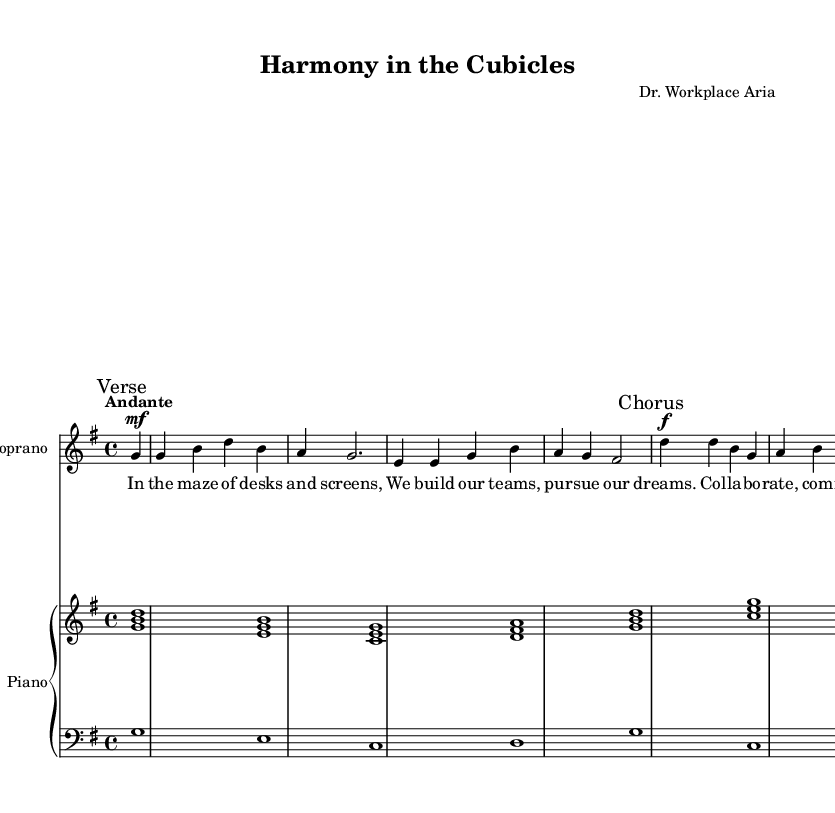What is the key signature of this music? The key signature is indicated at the beginning of the musical staff in the global variable. The presence of one sharp indicates it's in G major.
Answer: G major What is the time signature of this music? The time signature is shown in the global variable at the start of the score. It is noted as 4/4.
Answer: 4/4 What is the tempo marking of this music? The tempo marking is indicated in the global variable right above the vocal and instrumental parts. It states "Andante".
Answer: Andante How many measures are in the verse section? By counting the measures of the verse section provided in the soprano part below the verse mark, we find there are four measures.
Answer: Four How does the melody of the chorus compare to the verse? The chorus has a higher melodic range and dynamic, which can be inferred from the soprano part, identified by louder dynamics and a different pattern of notes compared to the verse section.
Answer: Higher melodic range What is the main theme of the lyrics? The lyrics focus on collaboration and teamwork, as evidenced by lines such as "We build our teams, pursue our dreams" in the verse.
Answer: Collaboration and teamwork What vocal type is indicated in the score? The score explicitly specifies "Soprano" at the start of the vocal part, denoting that this part is written for a soprano voice.
Answer: Soprano 